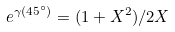Convert formula to latex. <formula><loc_0><loc_0><loc_500><loc_500>e ^ { \gamma ( 4 5 ^ { \circ } ) } = ( 1 + X ^ { 2 } ) / 2 X</formula> 